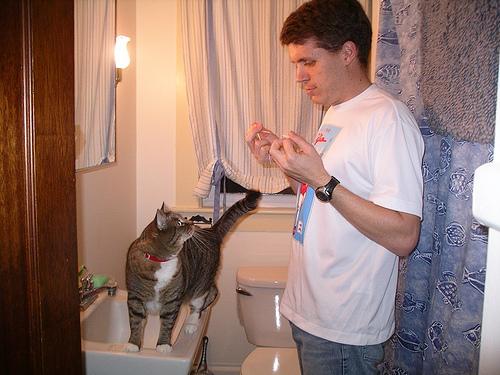What room is this?
Be succinct. Bathroom. What is the only clothing item that does not match?
Keep it brief. Shirt. What sparks the curiosity of the cat?
Give a very brief answer. Man. Is the sink running?
Write a very short answer. No. 